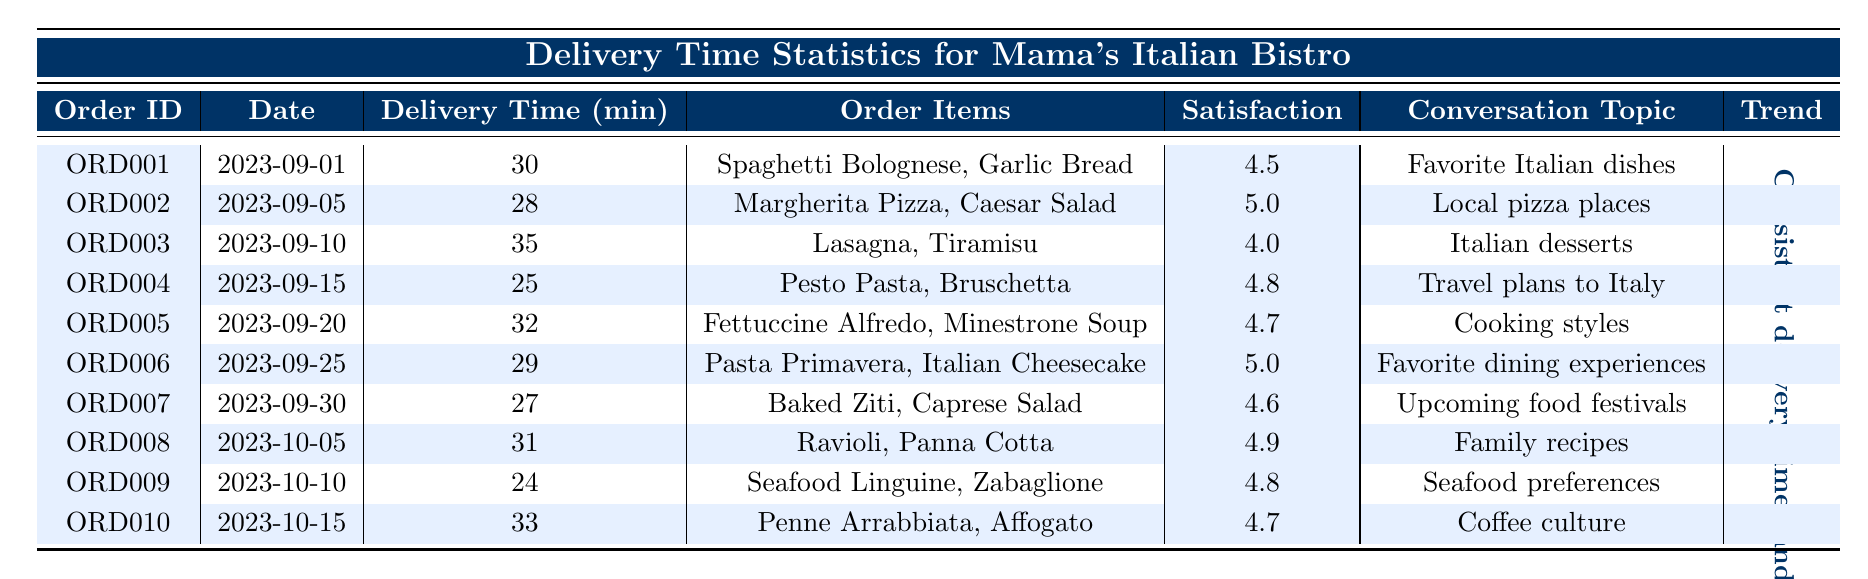What was the longest delivery time for an order? The longest delivery time recorded is 35 minutes, found in the entry for Order ID ORD003.
Answer: 35 minutes Which order received the highest customer satisfaction rating? The order with the highest satisfaction rating of 5.0 is for Order ID ORD002 and Order ID ORD006.
Answer: 5.0 What is the average delivery time for the orders? To find the average, sum all delivery times (30 + 28 + 35 + 25 + 32 + 29 + 27 + 31 + 24 + 33 =  29.4 minutes), then divide by the number of orders (10). The average delivery time is 294/10 = 29.4 minutes.
Answer: 29.4 minutes How many orders had a delivery time less than 30 minutes? The orders with delivery times less than 30 minutes are ORD002 (28 min), ORD004 (25 min), and ORD007 (27 min), totaling 3 orders.
Answer: 3 orders Was there an order with a customer satisfaction rating under 4.0? Yes, Order ID ORD003 has a satisfaction rating of 4.0, which is not under the stated threshold.
Answer: No What trend can be seen from the delivery times across the orders? An overall consistent delivery time is observed with values varying only slightly around the 30-minute mark, suggesting prompt service.
Answer: Consistent delivery times How many orders had a delivery time of 30 minutes or more? The orders with delivery times of 30 minutes or more are ORD001 (30 min), ORD003 (35 min), ORD005 (32 min), ORD006 (29 min), ORD008 (31 min), ORD009 (24 min), and ORD010 (33 min). Counting these gives a total of 5 orders.
Answer: 5 orders What was the topic discussed in the order with the lowest satisfaction rating? Order ID ORD003, which had the lowest satisfaction rating of 4.0, discussed "Italian desserts."
Answer: Italian desserts Which two orders were discussed together in the same topic during the conversation? Orders ORD001 (Favorite Italian dishes) and ORD004 (Travel plans to Italy) were both discussed in the context of food and Italy, creating a thematic connection.
Answer: ORD001 and ORD004 Which order had the lowest delivery time and what was discussed during the ride? The order with the lowest delivery time of 24 minutes is Order ID ORD009, where the conversation topic was "seafood preferences."
Answer: Order ID ORD009, seafood preferences 